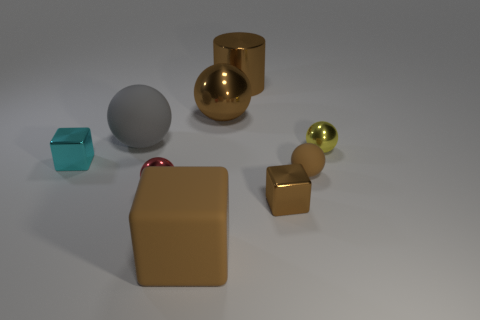Is there anything else that is the same color as the tiny matte object?
Your response must be concise. Yes. What number of other things are the same size as the brown rubber sphere?
Ensure brevity in your answer.  4. What material is the large sphere to the right of the rubber ball that is left of the big brown metallic cylinder on the right side of the gray matte sphere made of?
Provide a succinct answer. Metal. Does the small yellow ball have the same material as the large block left of the small yellow metal object?
Make the answer very short. No. Are there fewer red metallic things behind the large brown cylinder than metal things that are behind the yellow sphere?
Ensure brevity in your answer.  Yes. How many small brown objects have the same material as the gray object?
Provide a short and direct response. 1. There is a brown object behind the metal sphere behind the tiny yellow metallic ball; is there a large brown object right of it?
Your answer should be very brief. No. What number of balls are either metallic objects or tiny shiny objects?
Your answer should be very brief. 3. Do the gray rubber object and the big brown object in front of the tiny yellow thing have the same shape?
Provide a succinct answer. No. Are there fewer tiny brown metallic blocks right of the tiny brown rubber sphere than large brown shiny cylinders?
Ensure brevity in your answer.  Yes. 